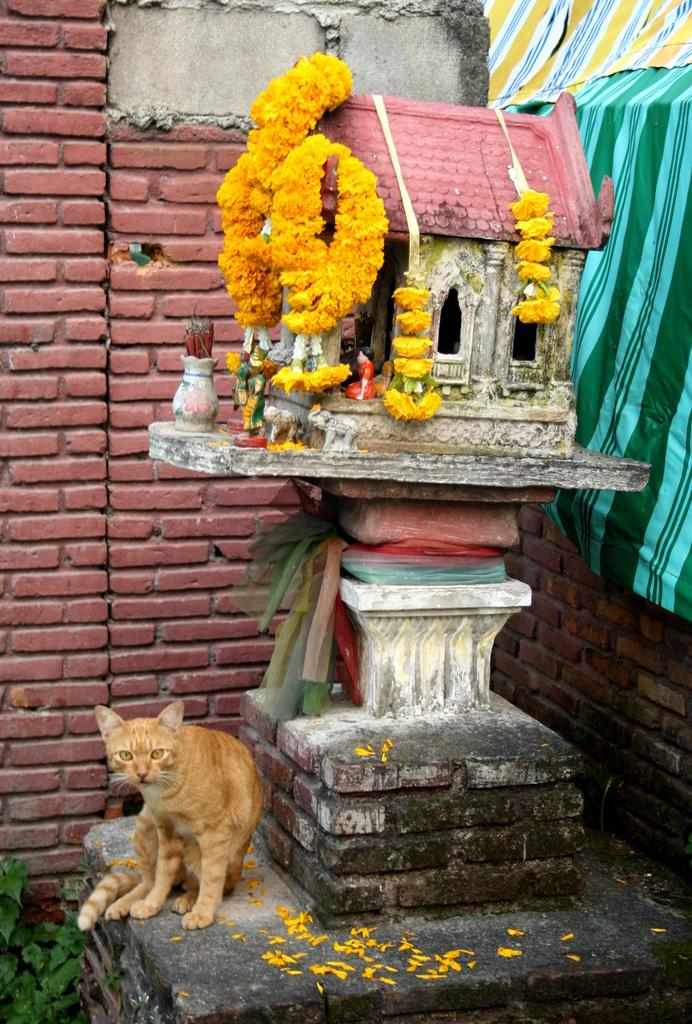What animal is at the bottom of the image? There is a cat at the bottom of the image. What is the main object in the middle of the image? There is a statue in the middle of the image. What type of plants can be seen in the image? There are flowers in the image. What is behind the statue in the image? There is a wall behind the statue. What type of birthday celebration is happening in the image? There is no indication of a birthday celebration in the image. Can you see a cub in the image? There is no cub present in the image. 